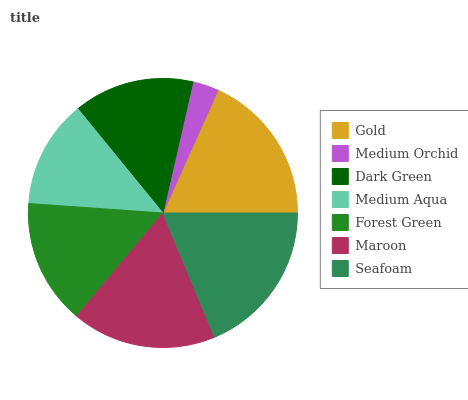Is Medium Orchid the minimum?
Answer yes or no. Yes. Is Seafoam the maximum?
Answer yes or no. Yes. Is Dark Green the minimum?
Answer yes or no. No. Is Dark Green the maximum?
Answer yes or no. No. Is Dark Green greater than Medium Orchid?
Answer yes or no. Yes. Is Medium Orchid less than Dark Green?
Answer yes or no. Yes. Is Medium Orchid greater than Dark Green?
Answer yes or no. No. Is Dark Green less than Medium Orchid?
Answer yes or no. No. Is Forest Green the high median?
Answer yes or no. Yes. Is Forest Green the low median?
Answer yes or no. Yes. Is Maroon the high median?
Answer yes or no. No. Is Medium Aqua the low median?
Answer yes or no. No. 